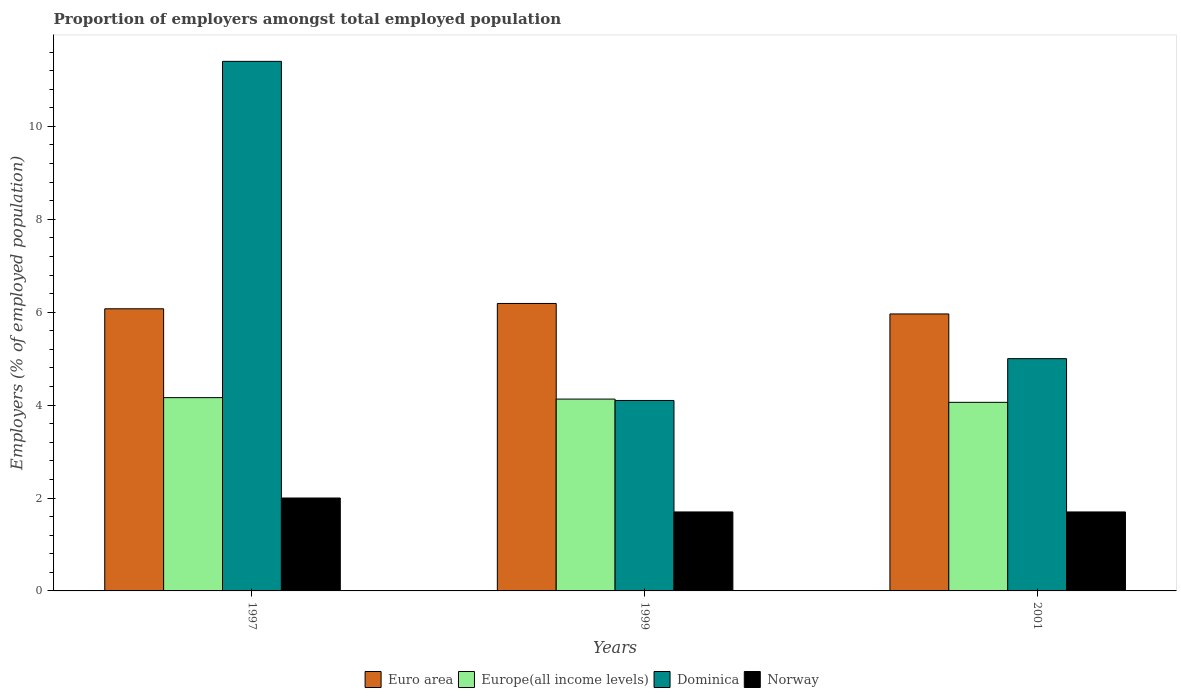Are the number of bars per tick equal to the number of legend labels?
Offer a terse response. Yes. Are the number of bars on each tick of the X-axis equal?
Your answer should be compact. Yes. How many bars are there on the 1st tick from the left?
Give a very brief answer. 4. How many bars are there on the 2nd tick from the right?
Offer a very short reply. 4. What is the label of the 2nd group of bars from the left?
Ensure brevity in your answer.  1999. In how many cases, is the number of bars for a given year not equal to the number of legend labels?
Your answer should be very brief. 0. What is the proportion of employers in Norway in 2001?
Offer a terse response. 1.7. Across all years, what is the minimum proportion of employers in Euro area?
Keep it short and to the point. 5.96. In which year was the proportion of employers in Europe(all income levels) maximum?
Your answer should be very brief. 1997. In which year was the proportion of employers in Europe(all income levels) minimum?
Your answer should be very brief. 2001. What is the total proportion of employers in Dominica in the graph?
Your response must be concise. 20.5. What is the difference between the proportion of employers in Euro area in 1999 and that in 2001?
Your answer should be very brief. 0.23. What is the difference between the proportion of employers in Europe(all income levels) in 2001 and the proportion of employers in Euro area in 1999?
Ensure brevity in your answer.  -2.13. What is the average proportion of employers in Euro area per year?
Provide a short and direct response. 6.07. In the year 1997, what is the difference between the proportion of employers in Europe(all income levels) and proportion of employers in Euro area?
Your response must be concise. -1.91. In how many years, is the proportion of employers in Euro area greater than 10.4 %?
Make the answer very short. 0. What is the ratio of the proportion of employers in Europe(all income levels) in 1999 to that in 2001?
Give a very brief answer. 1.02. Is the difference between the proportion of employers in Europe(all income levels) in 1997 and 2001 greater than the difference between the proportion of employers in Euro area in 1997 and 2001?
Offer a terse response. No. What is the difference between the highest and the second highest proportion of employers in Euro area?
Offer a very short reply. 0.11. What is the difference between the highest and the lowest proportion of employers in Dominica?
Make the answer very short. 7.3. Is the sum of the proportion of employers in Europe(all income levels) in 1999 and 2001 greater than the maximum proportion of employers in Dominica across all years?
Keep it short and to the point. No. What does the 2nd bar from the left in 2001 represents?
Provide a succinct answer. Europe(all income levels). What does the 2nd bar from the right in 2001 represents?
Provide a succinct answer. Dominica. Are all the bars in the graph horizontal?
Make the answer very short. No. How many years are there in the graph?
Offer a terse response. 3. What is the difference between two consecutive major ticks on the Y-axis?
Provide a succinct answer. 2. Are the values on the major ticks of Y-axis written in scientific E-notation?
Ensure brevity in your answer.  No. Does the graph contain any zero values?
Give a very brief answer. No. Does the graph contain grids?
Provide a succinct answer. No. How are the legend labels stacked?
Ensure brevity in your answer.  Horizontal. What is the title of the graph?
Offer a terse response. Proportion of employers amongst total employed population. What is the label or title of the Y-axis?
Make the answer very short. Employers (% of employed population). What is the Employers (% of employed population) in Euro area in 1997?
Your response must be concise. 6.07. What is the Employers (% of employed population) in Europe(all income levels) in 1997?
Make the answer very short. 4.16. What is the Employers (% of employed population) of Dominica in 1997?
Ensure brevity in your answer.  11.4. What is the Employers (% of employed population) of Norway in 1997?
Your answer should be very brief. 2. What is the Employers (% of employed population) of Euro area in 1999?
Your answer should be very brief. 6.19. What is the Employers (% of employed population) in Europe(all income levels) in 1999?
Your answer should be compact. 4.13. What is the Employers (% of employed population) in Dominica in 1999?
Your answer should be compact. 4.1. What is the Employers (% of employed population) in Norway in 1999?
Your answer should be compact. 1.7. What is the Employers (% of employed population) of Euro area in 2001?
Provide a short and direct response. 5.96. What is the Employers (% of employed population) of Europe(all income levels) in 2001?
Your response must be concise. 4.06. What is the Employers (% of employed population) of Norway in 2001?
Give a very brief answer. 1.7. Across all years, what is the maximum Employers (% of employed population) of Euro area?
Offer a terse response. 6.19. Across all years, what is the maximum Employers (% of employed population) in Europe(all income levels)?
Ensure brevity in your answer.  4.16. Across all years, what is the maximum Employers (% of employed population) of Dominica?
Make the answer very short. 11.4. Across all years, what is the minimum Employers (% of employed population) of Euro area?
Offer a terse response. 5.96. Across all years, what is the minimum Employers (% of employed population) in Europe(all income levels)?
Keep it short and to the point. 4.06. Across all years, what is the minimum Employers (% of employed population) of Dominica?
Your answer should be compact. 4.1. Across all years, what is the minimum Employers (% of employed population) of Norway?
Provide a short and direct response. 1.7. What is the total Employers (% of employed population) in Euro area in the graph?
Your response must be concise. 18.22. What is the total Employers (% of employed population) in Europe(all income levels) in the graph?
Your response must be concise. 12.35. What is the total Employers (% of employed population) of Dominica in the graph?
Give a very brief answer. 20.5. What is the difference between the Employers (% of employed population) of Euro area in 1997 and that in 1999?
Offer a terse response. -0.11. What is the difference between the Employers (% of employed population) of Europe(all income levels) in 1997 and that in 1999?
Give a very brief answer. 0.03. What is the difference between the Employers (% of employed population) in Euro area in 1997 and that in 2001?
Ensure brevity in your answer.  0.11. What is the difference between the Employers (% of employed population) in Europe(all income levels) in 1997 and that in 2001?
Provide a short and direct response. 0.1. What is the difference between the Employers (% of employed population) in Norway in 1997 and that in 2001?
Your answer should be compact. 0.3. What is the difference between the Employers (% of employed population) of Euro area in 1999 and that in 2001?
Provide a short and direct response. 0.23. What is the difference between the Employers (% of employed population) of Europe(all income levels) in 1999 and that in 2001?
Your answer should be compact. 0.07. What is the difference between the Employers (% of employed population) of Norway in 1999 and that in 2001?
Offer a very short reply. 0. What is the difference between the Employers (% of employed population) of Euro area in 1997 and the Employers (% of employed population) of Europe(all income levels) in 1999?
Provide a succinct answer. 1.94. What is the difference between the Employers (% of employed population) in Euro area in 1997 and the Employers (% of employed population) in Dominica in 1999?
Your answer should be compact. 1.97. What is the difference between the Employers (% of employed population) of Euro area in 1997 and the Employers (% of employed population) of Norway in 1999?
Your answer should be compact. 4.37. What is the difference between the Employers (% of employed population) in Europe(all income levels) in 1997 and the Employers (% of employed population) in Dominica in 1999?
Your answer should be compact. 0.06. What is the difference between the Employers (% of employed population) of Europe(all income levels) in 1997 and the Employers (% of employed population) of Norway in 1999?
Provide a succinct answer. 2.46. What is the difference between the Employers (% of employed population) of Euro area in 1997 and the Employers (% of employed population) of Europe(all income levels) in 2001?
Offer a terse response. 2.01. What is the difference between the Employers (% of employed population) in Euro area in 1997 and the Employers (% of employed population) in Dominica in 2001?
Make the answer very short. 1.07. What is the difference between the Employers (% of employed population) of Euro area in 1997 and the Employers (% of employed population) of Norway in 2001?
Your response must be concise. 4.37. What is the difference between the Employers (% of employed population) of Europe(all income levels) in 1997 and the Employers (% of employed population) of Dominica in 2001?
Provide a short and direct response. -0.84. What is the difference between the Employers (% of employed population) in Europe(all income levels) in 1997 and the Employers (% of employed population) in Norway in 2001?
Offer a very short reply. 2.46. What is the difference between the Employers (% of employed population) of Euro area in 1999 and the Employers (% of employed population) of Europe(all income levels) in 2001?
Make the answer very short. 2.13. What is the difference between the Employers (% of employed population) of Euro area in 1999 and the Employers (% of employed population) of Dominica in 2001?
Your response must be concise. 1.19. What is the difference between the Employers (% of employed population) in Euro area in 1999 and the Employers (% of employed population) in Norway in 2001?
Provide a short and direct response. 4.49. What is the difference between the Employers (% of employed population) in Europe(all income levels) in 1999 and the Employers (% of employed population) in Dominica in 2001?
Offer a terse response. -0.87. What is the difference between the Employers (% of employed population) of Europe(all income levels) in 1999 and the Employers (% of employed population) of Norway in 2001?
Give a very brief answer. 2.43. What is the difference between the Employers (% of employed population) in Dominica in 1999 and the Employers (% of employed population) in Norway in 2001?
Give a very brief answer. 2.4. What is the average Employers (% of employed population) of Euro area per year?
Make the answer very short. 6.07. What is the average Employers (% of employed population) of Europe(all income levels) per year?
Your answer should be compact. 4.12. What is the average Employers (% of employed population) in Dominica per year?
Your answer should be very brief. 6.83. What is the average Employers (% of employed population) of Norway per year?
Ensure brevity in your answer.  1.8. In the year 1997, what is the difference between the Employers (% of employed population) of Euro area and Employers (% of employed population) of Europe(all income levels)?
Offer a very short reply. 1.91. In the year 1997, what is the difference between the Employers (% of employed population) in Euro area and Employers (% of employed population) in Dominica?
Your answer should be compact. -5.33. In the year 1997, what is the difference between the Employers (% of employed population) of Euro area and Employers (% of employed population) of Norway?
Offer a terse response. 4.07. In the year 1997, what is the difference between the Employers (% of employed population) in Europe(all income levels) and Employers (% of employed population) in Dominica?
Ensure brevity in your answer.  -7.24. In the year 1997, what is the difference between the Employers (% of employed population) in Europe(all income levels) and Employers (% of employed population) in Norway?
Ensure brevity in your answer.  2.16. In the year 1997, what is the difference between the Employers (% of employed population) of Dominica and Employers (% of employed population) of Norway?
Offer a terse response. 9.4. In the year 1999, what is the difference between the Employers (% of employed population) of Euro area and Employers (% of employed population) of Europe(all income levels)?
Give a very brief answer. 2.06. In the year 1999, what is the difference between the Employers (% of employed population) of Euro area and Employers (% of employed population) of Dominica?
Your answer should be very brief. 2.09. In the year 1999, what is the difference between the Employers (% of employed population) in Euro area and Employers (% of employed population) in Norway?
Offer a very short reply. 4.49. In the year 1999, what is the difference between the Employers (% of employed population) of Europe(all income levels) and Employers (% of employed population) of Dominica?
Your response must be concise. 0.03. In the year 1999, what is the difference between the Employers (% of employed population) in Europe(all income levels) and Employers (% of employed population) in Norway?
Offer a very short reply. 2.43. In the year 1999, what is the difference between the Employers (% of employed population) of Dominica and Employers (% of employed population) of Norway?
Give a very brief answer. 2.4. In the year 2001, what is the difference between the Employers (% of employed population) of Euro area and Employers (% of employed population) of Europe(all income levels)?
Your response must be concise. 1.9. In the year 2001, what is the difference between the Employers (% of employed population) of Euro area and Employers (% of employed population) of Dominica?
Keep it short and to the point. 0.96. In the year 2001, what is the difference between the Employers (% of employed population) in Euro area and Employers (% of employed population) in Norway?
Your response must be concise. 4.26. In the year 2001, what is the difference between the Employers (% of employed population) in Europe(all income levels) and Employers (% of employed population) in Dominica?
Your answer should be compact. -0.94. In the year 2001, what is the difference between the Employers (% of employed population) in Europe(all income levels) and Employers (% of employed population) in Norway?
Offer a terse response. 2.36. In the year 2001, what is the difference between the Employers (% of employed population) of Dominica and Employers (% of employed population) of Norway?
Ensure brevity in your answer.  3.3. What is the ratio of the Employers (% of employed population) in Euro area in 1997 to that in 1999?
Provide a short and direct response. 0.98. What is the ratio of the Employers (% of employed population) in Europe(all income levels) in 1997 to that in 1999?
Your answer should be compact. 1.01. What is the ratio of the Employers (% of employed population) of Dominica in 1997 to that in 1999?
Provide a succinct answer. 2.78. What is the ratio of the Employers (% of employed population) in Norway in 1997 to that in 1999?
Give a very brief answer. 1.18. What is the ratio of the Employers (% of employed population) in Euro area in 1997 to that in 2001?
Keep it short and to the point. 1.02. What is the ratio of the Employers (% of employed population) of Europe(all income levels) in 1997 to that in 2001?
Offer a very short reply. 1.02. What is the ratio of the Employers (% of employed population) in Dominica in 1997 to that in 2001?
Your response must be concise. 2.28. What is the ratio of the Employers (% of employed population) in Norway in 1997 to that in 2001?
Make the answer very short. 1.18. What is the ratio of the Employers (% of employed population) of Euro area in 1999 to that in 2001?
Ensure brevity in your answer.  1.04. What is the ratio of the Employers (% of employed population) of Europe(all income levels) in 1999 to that in 2001?
Keep it short and to the point. 1.02. What is the ratio of the Employers (% of employed population) in Dominica in 1999 to that in 2001?
Offer a very short reply. 0.82. What is the difference between the highest and the second highest Employers (% of employed population) of Euro area?
Your answer should be very brief. 0.11. What is the difference between the highest and the second highest Employers (% of employed population) of Europe(all income levels)?
Ensure brevity in your answer.  0.03. What is the difference between the highest and the second highest Employers (% of employed population) in Dominica?
Your response must be concise. 6.4. What is the difference between the highest and the lowest Employers (% of employed population) in Euro area?
Keep it short and to the point. 0.23. What is the difference between the highest and the lowest Employers (% of employed population) in Europe(all income levels)?
Your answer should be compact. 0.1. 